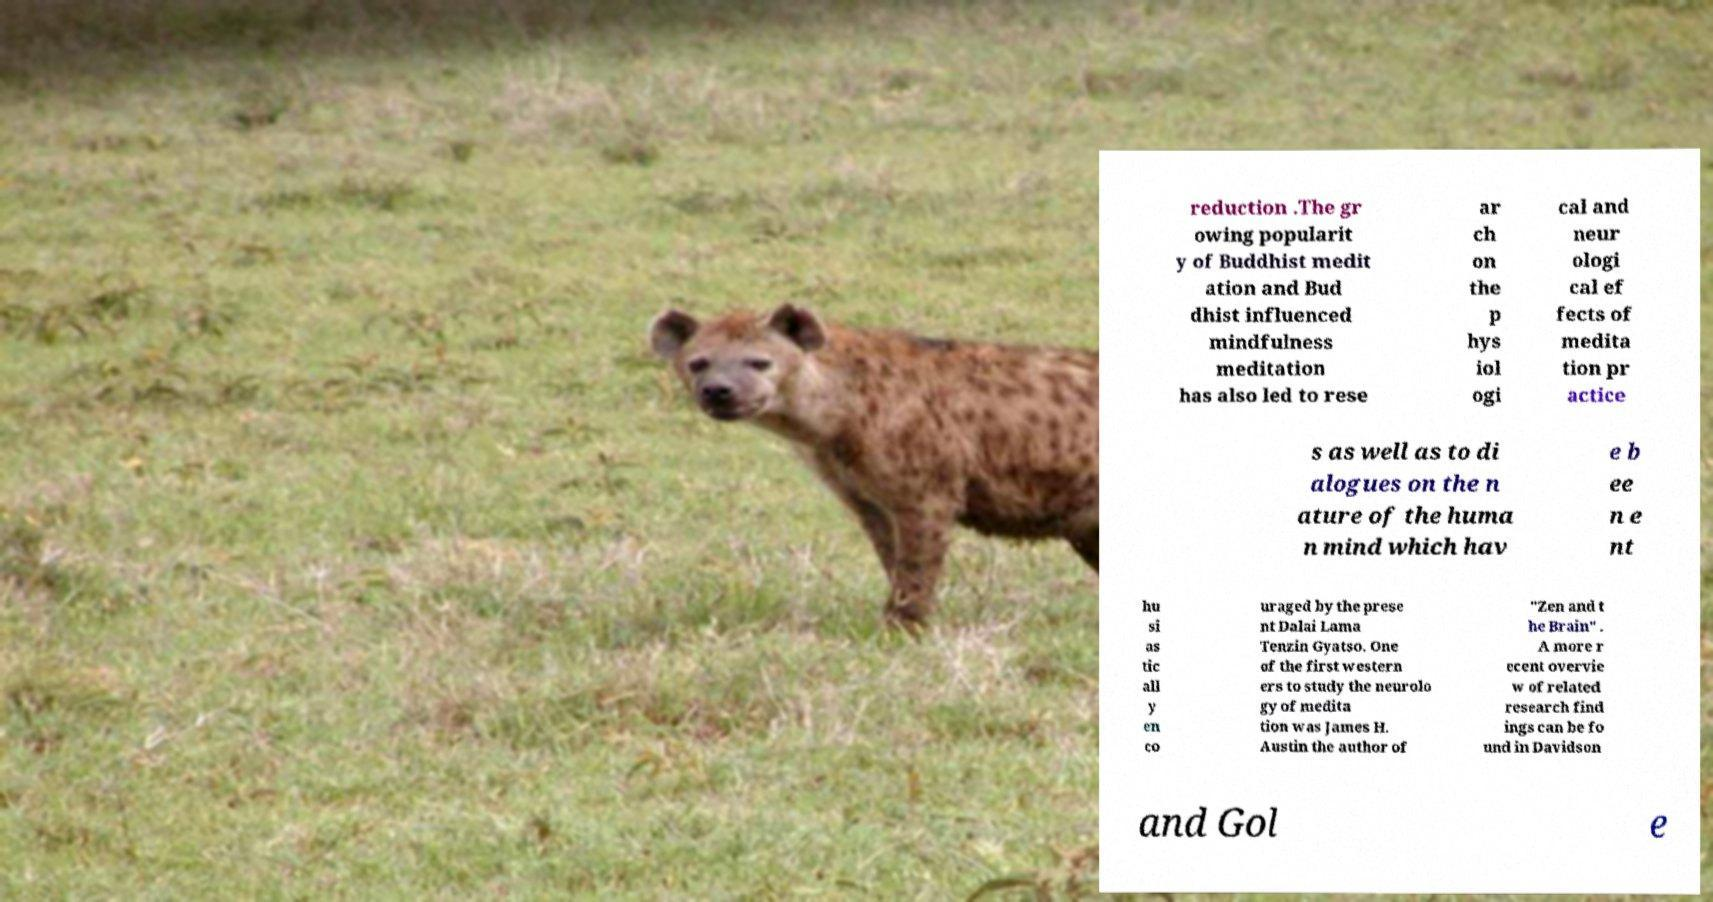Can you accurately transcribe the text from the provided image for me? reduction .The gr owing popularit y of Buddhist medit ation and Bud dhist influenced mindfulness meditation has also led to rese ar ch on the p hys iol ogi cal and neur ologi cal ef fects of medita tion pr actice s as well as to di alogues on the n ature of the huma n mind which hav e b ee n e nt hu si as tic all y en co uraged by the prese nt Dalai Lama Tenzin Gyatso. One of the first western ers to study the neurolo gy of medita tion was James H. Austin the author of "Zen and t he Brain" . A more r ecent overvie w of related research find ings can be fo und in Davidson and Gol e 